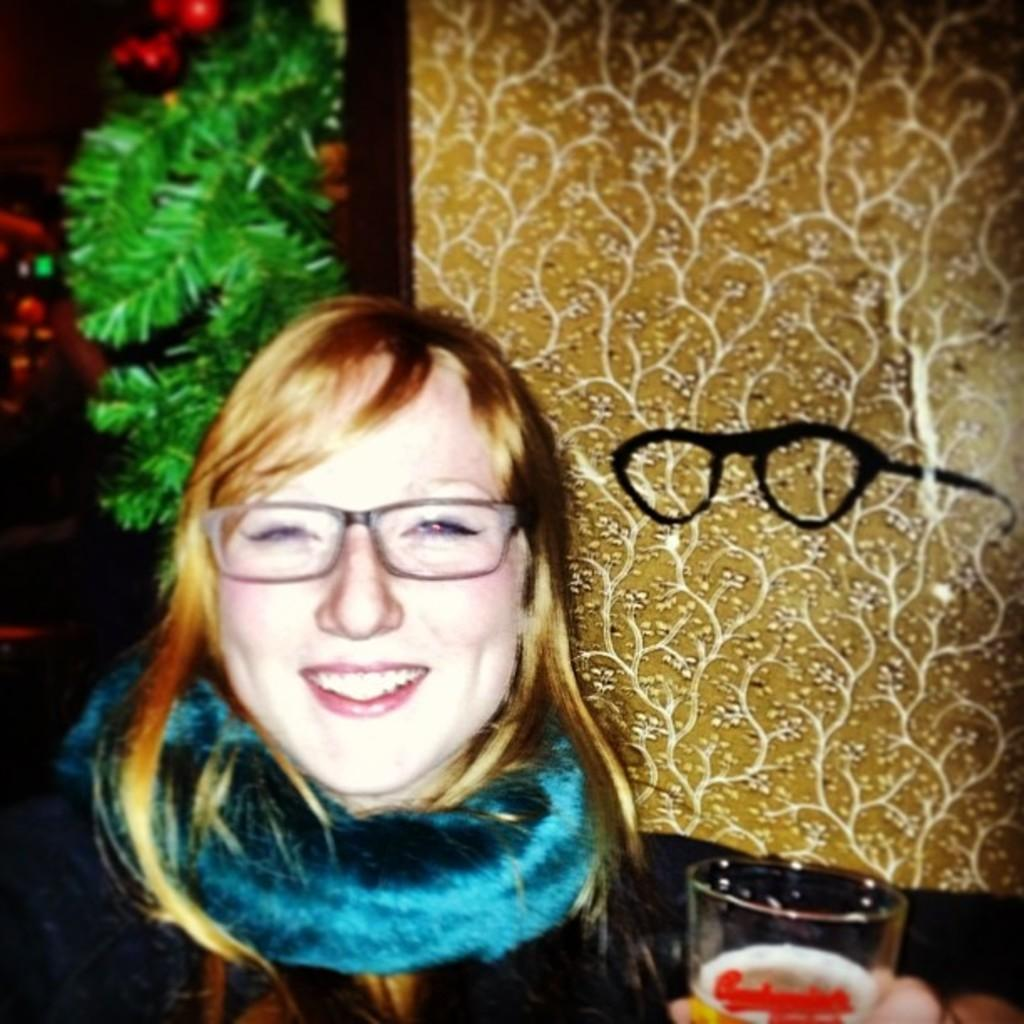Who is the main subject in the image? There is a lady in the center of the image. What accessories is the lady wearing? The lady is wearing glasses and a scarf. What is the lady holding in the image? The lady is holding a glass with a drink. What can be seen in the background of the image? There is a board and streamers visible in the background of the image. How many clams are sitting on the lady's shoulder in the image? There are no clams present in the image. Can you tell me how many lizards are crawling on the board in the background? There are no lizards visible on the board in the background of the image. 